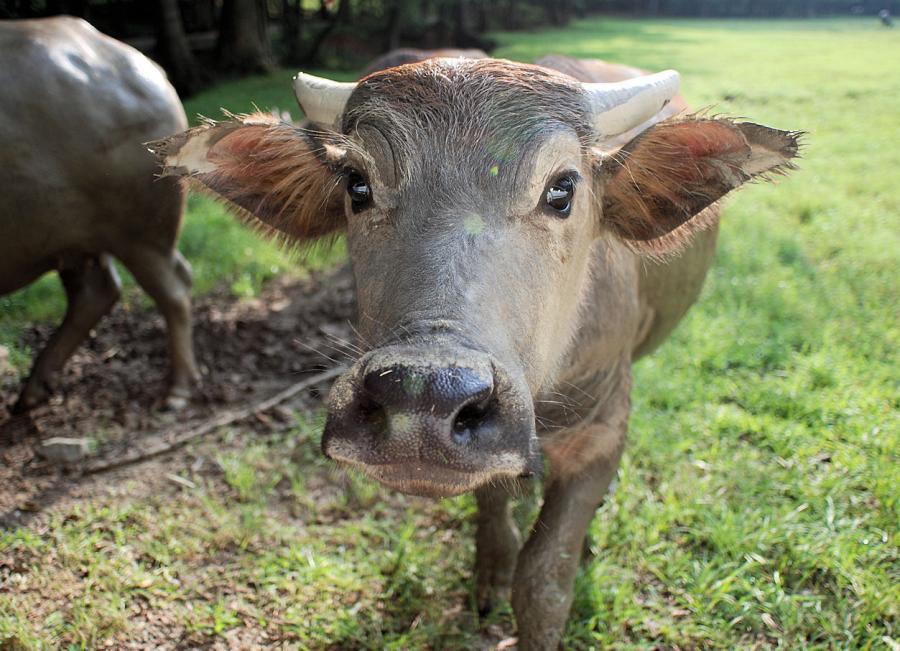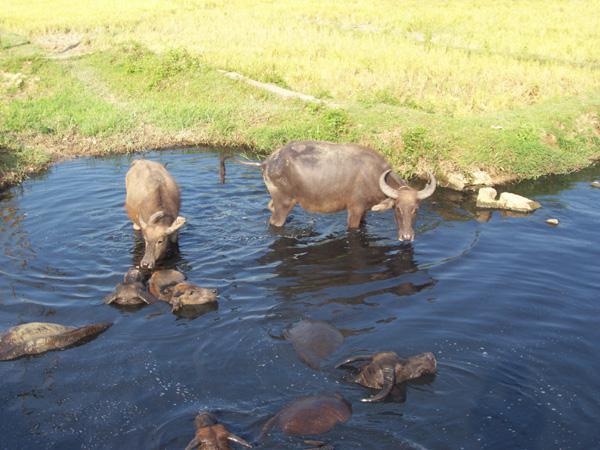The first image is the image on the left, the second image is the image on the right. Evaluate the accuracy of this statement regarding the images: "There is water in the image on the left.". Is it true? Answer yes or no. No. 